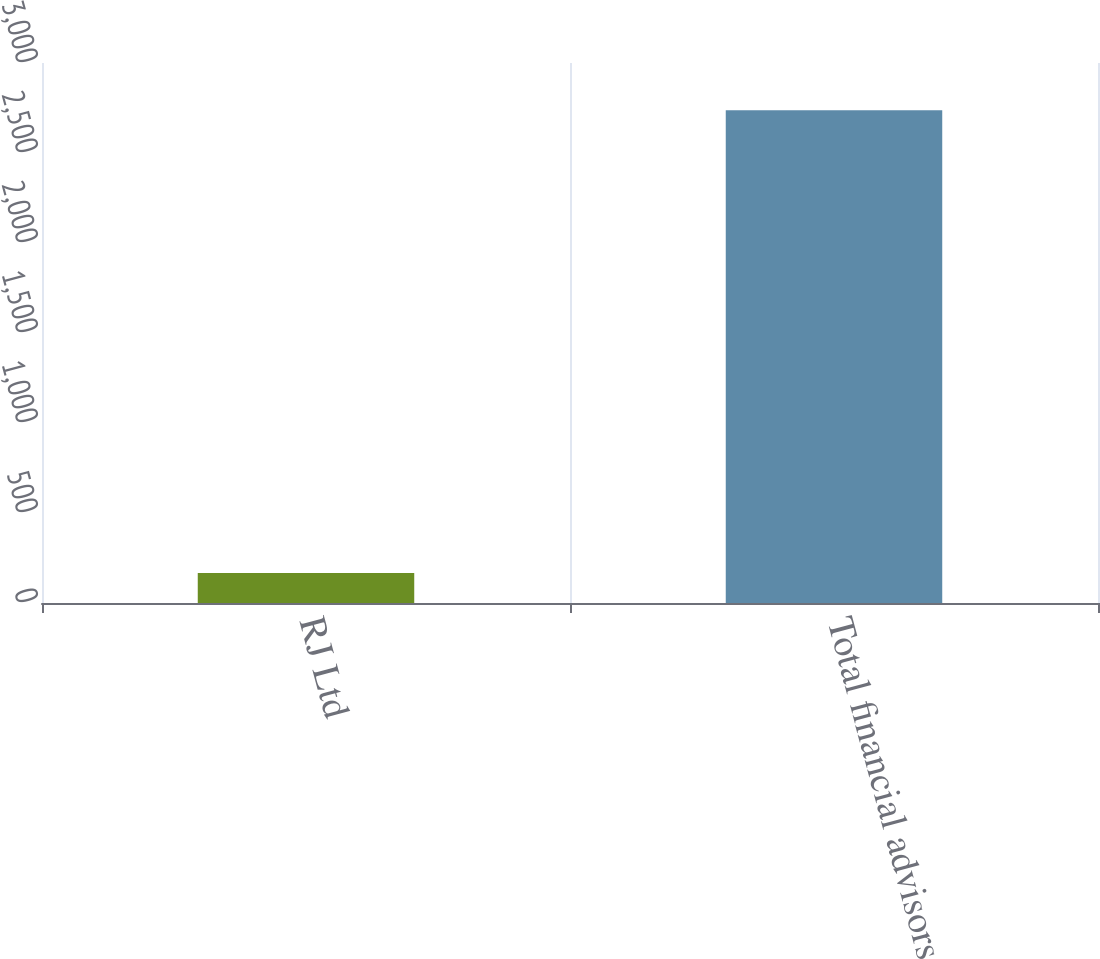<chart> <loc_0><loc_0><loc_500><loc_500><bar_chart><fcel>RJ Ltd<fcel>Total financial advisors<nl><fcel>167<fcel>2738<nl></chart> 